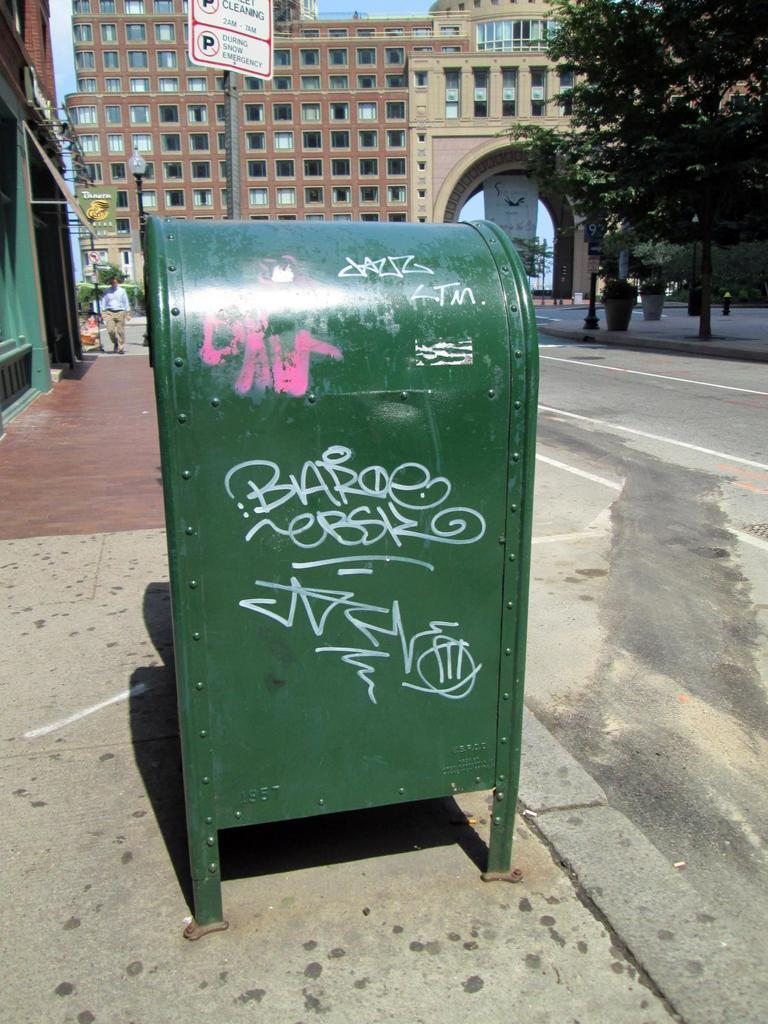<image>
Describe the image concisely. Green mailbox with graffitti on it under a sign which says no parking. 